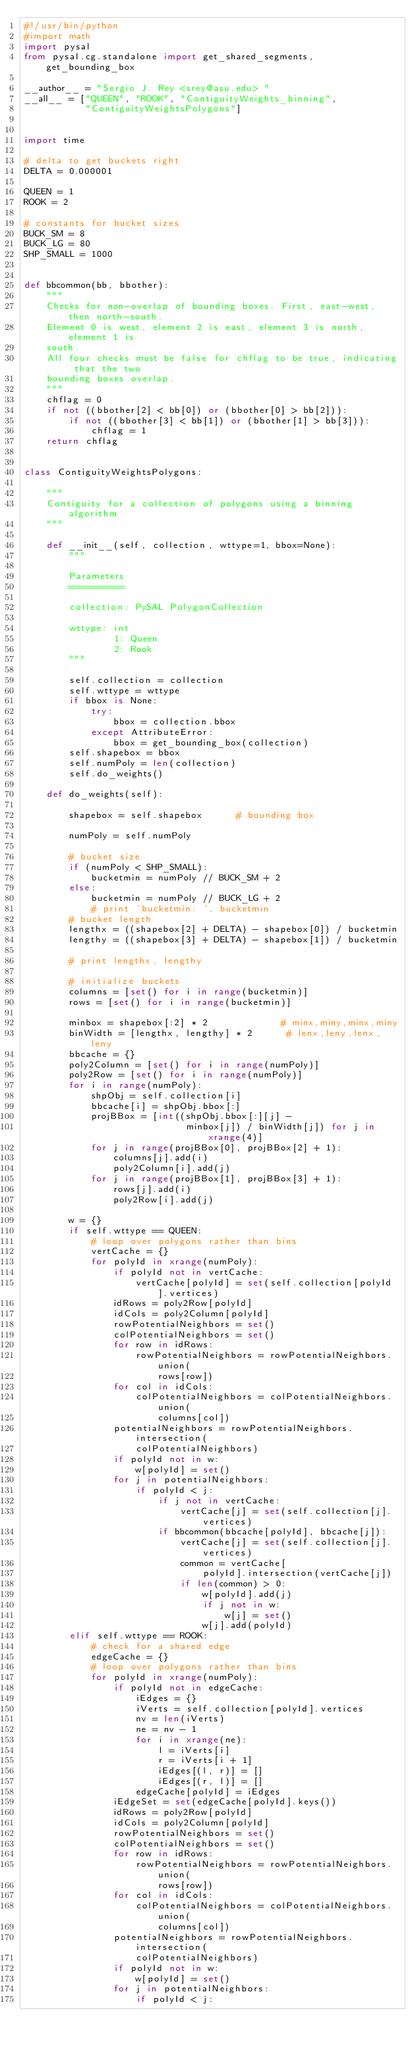<code> <loc_0><loc_0><loc_500><loc_500><_Python_>#!/usr/bin/python
#import math
import pysal
from pysal.cg.standalone import get_shared_segments, get_bounding_box

__author__ = "Sergio J. Rey <srey@asu.edu> "
__all__ = ["QUEEN", "ROOK", "ContiguityWeights_binning",
           "ContiguityWeightsPolygons"]


import time

# delta to get buckets right
DELTA = 0.000001

QUEEN = 1
ROOK = 2

# constants for bucket sizes
BUCK_SM = 8
BUCK_LG = 80
SHP_SMALL = 1000


def bbcommon(bb, bbother):
    """
    Checks for non-overlap of bounding boxes. First, east-west, then north-south.
    Element 0 is west, element 2 is east, element 3 is north, element 1 is
    south.
    All four checks must be false for chflag to be true, indicating that the two
    bounding boxes overlap.
    """
    chflag = 0
    if not ((bbother[2] < bb[0]) or (bbother[0] > bb[2])):
        if not ((bbother[3] < bb[1]) or (bbother[1] > bb[3])):
            chflag = 1
    return chflag


class ContiguityWeightsPolygons:

    """
    Contiguity for a collection of polygons using a binning algorithm
    """

    def __init__(self, collection, wttype=1, bbox=None):
        """

        Parameters
        ==========

        collection: PySAL PolygonCollection 

        wttype: int
                1: Queen
                2: Rook
        """

        self.collection = collection
        self.wttype = wttype
        if bbox is None:
            try:
                bbox = collection.bbox
            except AttributeError:
                bbox = get_bounding_box(collection)
        self.shapebox = bbox
        self.numPoly = len(collection)
        self.do_weights()

    def do_weights(self):

        shapebox = self.shapebox      # bounding box

        numPoly = self.numPoly

        # bucket size
        if (numPoly < SHP_SMALL):
            bucketmin = numPoly // BUCK_SM + 2
        else:
            bucketmin = numPoly // BUCK_LG + 2
            # print 'bucketmin: ', bucketmin
        # bucket length
        lengthx = ((shapebox[2] + DELTA) - shapebox[0]) / bucketmin
        lengthy = ((shapebox[3] + DELTA) - shapebox[1]) / bucketmin

        # print lengthx, lengthy

        # initialize buckets
        columns = [set() for i in range(bucketmin)]
        rows = [set() for i in range(bucketmin)]

        minbox = shapebox[:2] * 2             # minx,miny,minx,miny
        binWidth = [lengthx, lengthy] * 2      # lenx,leny,lenx,leny
        bbcache = {}
        poly2Column = [set() for i in range(numPoly)]
        poly2Row = [set() for i in range(numPoly)]
        for i in range(numPoly):
            shpObj = self.collection[i]
            bbcache[i] = shpObj.bbox[:]
            projBBox = [int((shpObj.bbox[:][j] -
                             minbox[j]) / binWidth[j]) for j in xrange(4)]
            for j in range(projBBox[0], projBBox[2] + 1):
                columns[j].add(i)
                poly2Column[i].add(j)
            for j in range(projBBox[1], projBBox[3] + 1):
                rows[j].add(i)
                poly2Row[i].add(j)

        w = {}
        if self.wttype == QUEEN:
            # loop over polygons rather than bins
            vertCache = {}
            for polyId in xrange(numPoly):
                if polyId not in vertCache:
                    vertCache[polyId] = set(self.collection[polyId].vertices)
                idRows = poly2Row[polyId]
                idCols = poly2Column[polyId]
                rowPotentialNeighbors = set()
                colPotentialNeighbors = set()
                for row in idRows:
                    rowPotentialNeighbors = rowPotentialNeighbors.union(
                        rows[row])
                for col in idCols:
                    colPotentialNeighbors = colPotentialNeighbors.union(
                        columns[col])
                potentialNeighbors = rowPotentialNeighbors.intersection(
                    colPotentialNeighbors)
                if polyId not in w:
                    w[polyId] = set()
                for j in potentialNeighbors:
                    if polyId < j:
                        if j not in vertCache:
                            vertCache[j] = set(self.collection[j].vertices)
                        if bbcommon(bbcache[polyId], bbcache[j]):
                            vertCache[j] = set(self.collection[j].vertices)
                            common = vertCache[
                                polyId].intersection(vertCache[j])
                            if len(common) > 0:
                                w[polyId].add(j)
                                if j not in w:
                                    w[j] = set()
                                w[j].add(polyId)
        elif self.wttype == ROOK:
            # check for a shared edge
            edgeCache = {}
            # loop over polygons rather than bins
            for polyId in xrange(numPoly):
                if polyId not in edgeCache:
                    iEdges = {}
                    iVerts = self.collection[polyId].vertices
                    nv = len(iVerts)
                    ne = nv - 1
                    for i in xrange(ne):
                        l = iVerts[i]
                        r = iVerts[i + 1]
                        iEdges[(l, r)] = []
                        iEdges[(r, l)] = []
                    edgeCache[polyId] = iEdges
                iEdgeSet = set(edgeCache[polyId].keys())
                idRows = poly2Row[polyId]
                idCols = poly2Column[polyId]
                rowPotentialNeighbors = set()
                colPotentialNeighbors = set()
                for row in idRows:
                    rowPotentialNeighbors = rowPotentialNeighbors.union(
                        rows[row])
                for col in idCols:
                    colPotentialNeighbors = colPotentialNeighbors.union(
                        columns[col])
                potentialNeighbors = rowPotentialNeighbors.intersection(
                    colPotentialNeighbors)
                if polyId not in w:
                    w[polyId] = set()
                for j in potentialNeighbors:
                    if polyId < j:</code> 